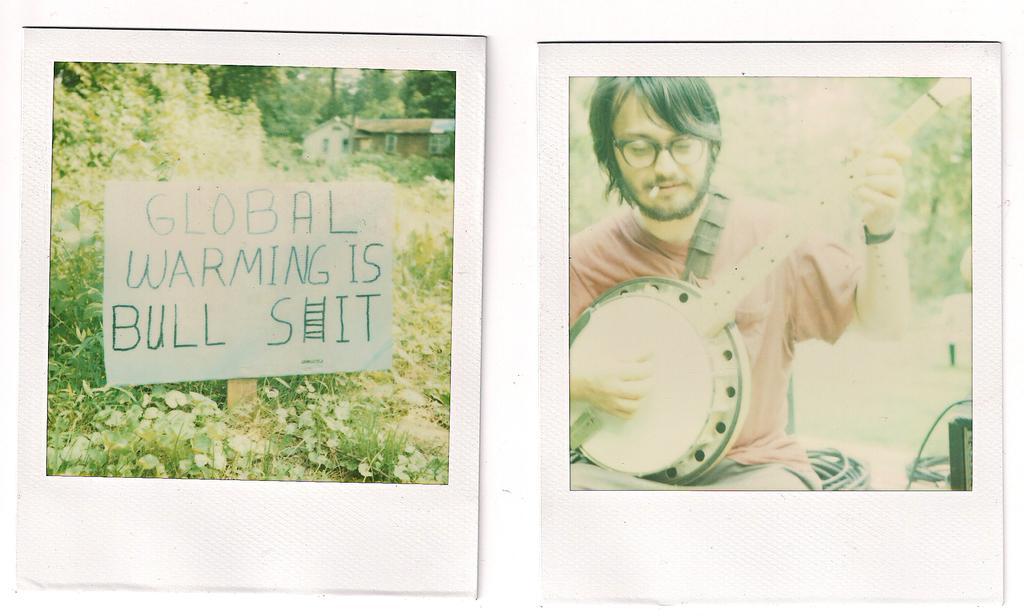In one or two sentences, can you explain what this image depicts? The image is a collage of two images. In the left there is a placard. There are trees and building in the image. In the right a person is playing a musical instrument. In the background there are trees. 